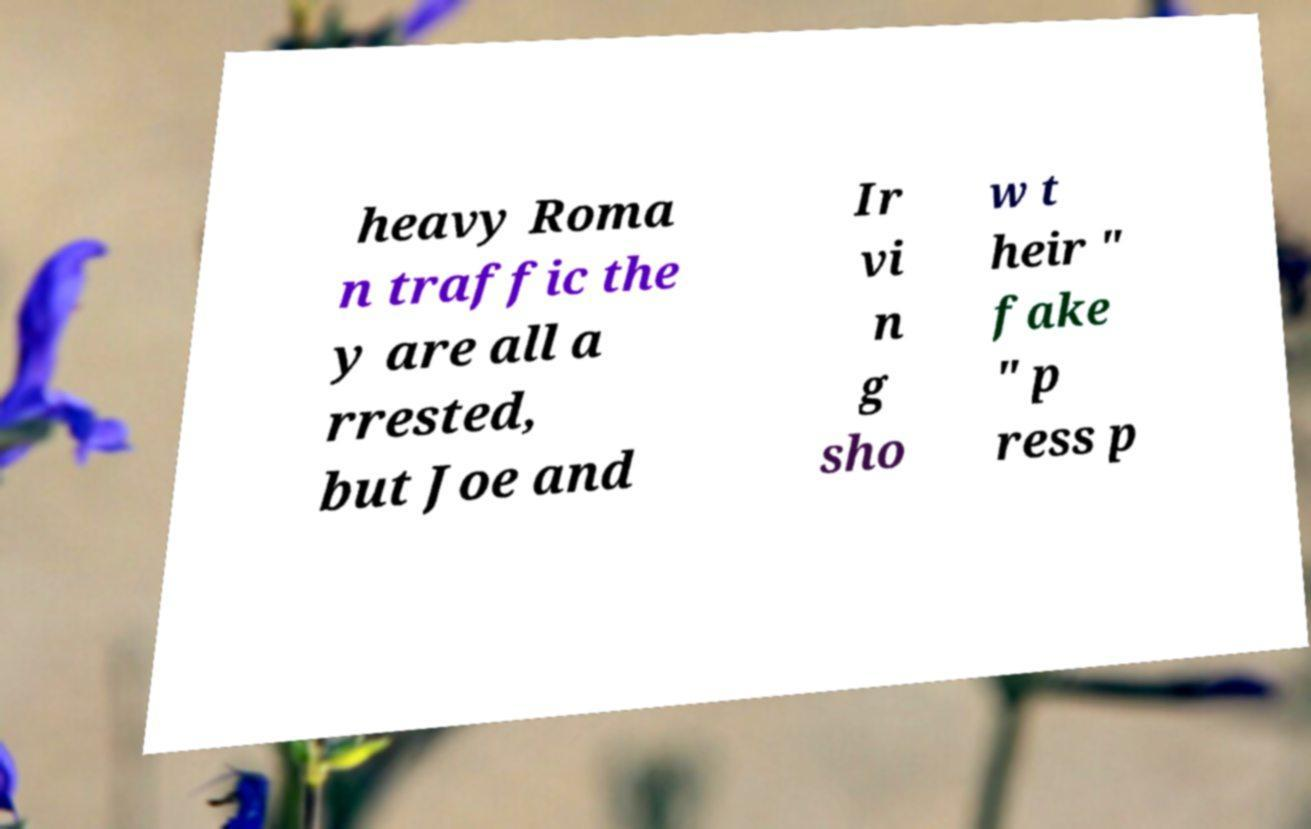I need the written content from this picture converted into text. Can you do that? heavy Roma n traffic the y are all a rrested, but Joe and Ir vi n g sho w t heir " fake " p ress p 